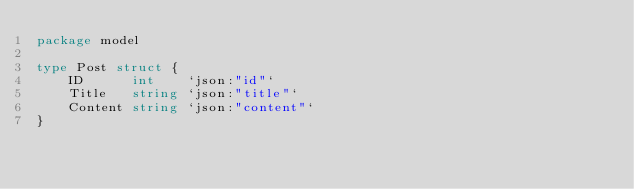Convert code to text. <code><loc_0><loc_0><loc_500><loc_500><_Go_>package model

type Post struct {
	ID      int    `json:"id"`
	Title   string `json:"title"`
	Content string `json:"content"`
}
</code> 